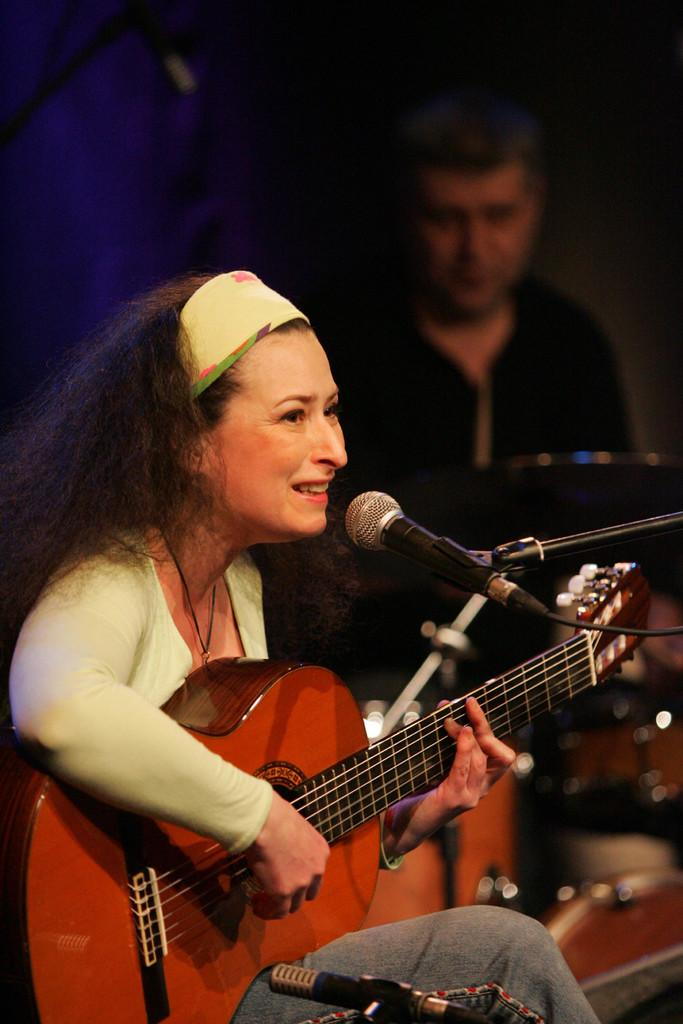Who is the main subject in the image? There is a woman in the image. What is the woman doing in the image? The woman is sitting in front of a microphone, playing a guitar, and singing. Is there anyone else in the image? Yes, there is a man in the image. What can be observed about the background of the image? The background of the image is dark. What type of branch can be seen in the woman's hand while she is singing? There is no branch visible in the woman's hand or in the image. How does the taste of the song being sung by the woman compare to that of a toad? The taste of a song cannot be compared to that of a toad, as taste is a sensory experience related to food and drink, not music. 